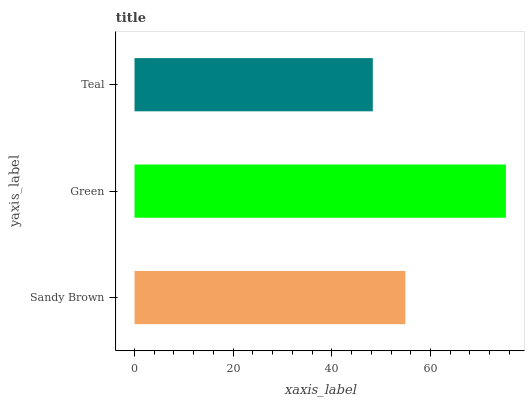Is Teal the minimum?
Answer yes or no. Yes. Is Green the maximum?
Answer yes or no. Yes. Is Green the minimum?
Answer yes or no. No. Is Teal the maximum?
Answer yes or no. No. Is Green greater than Teal?
Answer yes or no. Yes. Is Teal less than Green?
Answer yes or no. Yes. Is Teal greater than Green?
Answer yes or no. No. Is Green less than Teal?
Answer yes or no. No. Is Sandy Brown the high median?
Answer yes or no. Yes. Is Sandy Brown the low median?
Answer yes or no. Yes. Is Teal the high median?
Answer yes or no. No. Is Green the low median?
Answer yes or no. No. 